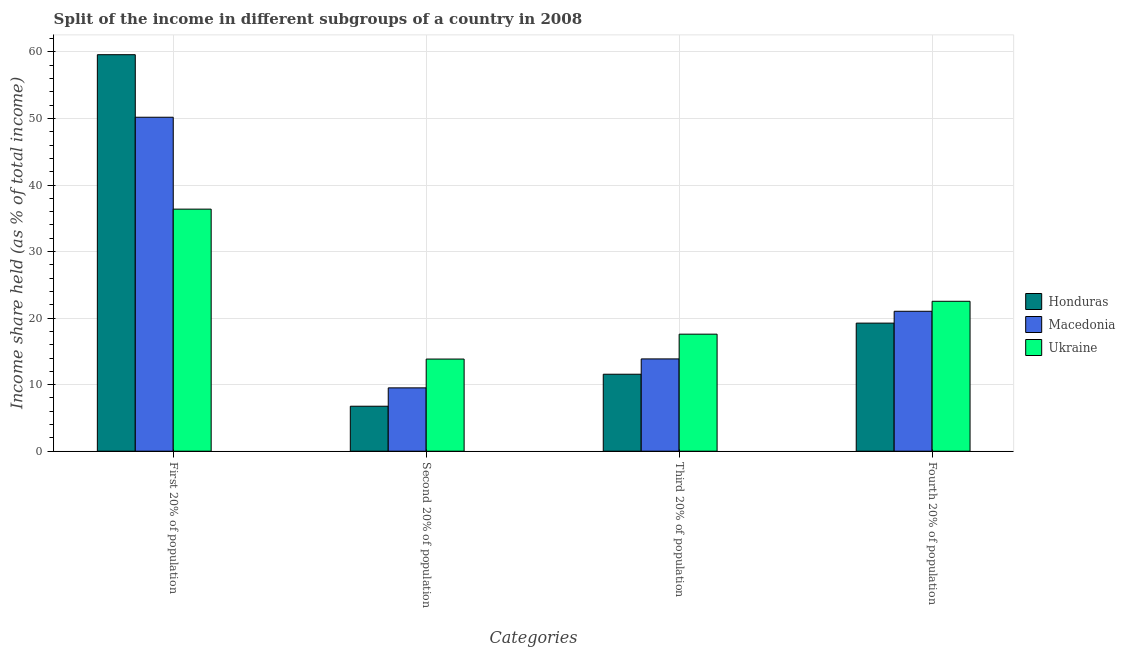How many groups of bars are there?
Your answer should be compact. 4. Are the number of bars per tick equal to the number of legend labels?
Your response must be concise. Yes. How many bars are there on the 2nd tick from the left?
Keep it short and to the point. 3. What is the label of the 4th group of bars from the left?
Offer a terse response. Fourth 20% of population. What is the share of the income held by fourth 20% of the population in Honduras?
Your answer should be very brief. 19.25. Across all countries, what is the maximum share of the income held by fourth 20% of the population?
Make the answer very short. 22.53. Across all countries, what is the minimum share of the income held by first 20% of the population?
Offer a very short reply. 36.38. In which country was the share of the income held by first 20% of the population maximum?
Your answer should be compact. Honduras. In which country was the share of the income held by third 20% of the population minimum?
Your response must be concise. Honduras. What is the total share of the income held by second 20% of the population in the graph?
Your answer should be very brief. 30.13. What is the difference between the share of the income held by third 20% of the population in Honduras and that in Ukraine?
Provide a succinct answer. -6.02. What is the difference between the share of the income held by third 20% of the population in Macedonia and the share of the income held by first 20% of the population in Honduras?
Your response must be concise. -45.72. What is the average share of the income held by fourth 20% of the population per country?
Keep it short and to the point. 20.94. What is the difference between the share of the income held by second 20% of the population and share of the income held by third 20% of the population in Ukraine?
Offer a very short reply. -3.74. In how many countries, is the share of the income held by first 20% of the population greater than 28 %?
Keep it short and to the point. 3. What is the ratio of the share of the income held by first 20% of the population in Honduras to that in Macedonia?
Offer a terse response. 1.19. What is the difference between the highest and the second highest share of the income held by first 20% of the population?
Give a very brief answer. 9.4. What is the difference between the highest and the lowest share of the income held by first 20% of the population?
Provide a succinct answer. 23.21. In how many countries, is the share of the income held by third 20% of the population greater than the average share of the income held by third 20% of the population taken over all countries?
Your response must be concise. 1. What does the 1st bar from the left in Second 20% of population represents?
Offer a terse response. Honduras. What does the 3rd bar from the right in Fourth 20% of population represents?
Your answer should be compact. Honduras. Is it the case that in every country, the sum of the share of the income held by first 20% of the population and share of the income held by second 20% of the population is greater than the share of the income held by third 20% of the population?
Keep it short and to the point. Yes. How many bars are there?
Offer a terse response. 12. How many countries are there in the graph?
Make the answer very short. 3. What is the difference between two consecutive major ticks on the Y-axis?
Ensure brevity in your answer.  10. Does the graph contain grids?
Give a very brief answer. Yes. Where does the legend appear in the graph?
Provide a succinct answer. Center right. How many legend labels are there?
Your answer should be very brief. 3. What is the title of the graph?
Offer a terse response. Split of the income in different subgroups of a country in 2008. What is the label or title of the X-axis?
Make the answer very short. Categories. What is the label or title of the Y-axis?
Give a very brief answer. Income share held (as % of total income). What is the Income share held (as % of total income) in Honduras in First 20% of population?
Provide a short and direct response. 59.59. What is the Income share held (as % of total income) in Macedonia in First 20% of population?
Offer a very short reply. 50.19. What is the Income share held (as % of total income) of Ukraine in First 20% of population?
Give a very brief answer. 36.38. What is the Income share held (as % of total income) of Honduras in Second 20% of population?
Provide a short and direct response. 6.76. What is the Income share held (as % of total income) of Macedonia in Second 20% of population?
Provide a short and direct response. 9.52. What is the Income share held (as % of total income) of Ukraine in Second 20% of population?
Make the answer very short. 13.85. What is the Income share held (as % of total income) of Honduras in Third 20% of population?
Provide a succinct answer. 11.57. What is the Income share held (as % of total income) of Macedonia in Third 20% of population?
Your response must be concise. 13.87. What is the Income share held (as % of total income) in Ukraine in Third 20% of population?
Keep it short and to the point. 17.59. What is the Income share held (as % of total income) in Honduras in Fourth 20% of population?
Keep it short and to the point. 19.25. What is the Income share held (as % of total income) in Macedonia in Fourth 20% of population?
Your answer should be very brief. 21.03. What is the Income share held (as % of total income) in Ukraine in Fourth 20% of population?
Ensure brevity in your answer.  22.53. Across all Categories, what is the maximum Income share held (as % of total income) of Honduras?
Keep it short and to the point. 59.59. Across all Categories, what is the maximum Income share held (as % of total income) of Macedonia?
Your response must be concise. 50.19. Across all Categories, what is the maximum Income share held (as % of total income) in Ukraine?
Make the answer very short. 36.38. Across all Categories, what is the minimum Income share held (as % of total income) in Honduras?
Ensure brevity in your answer.  6.76. Across all Categories, what is the minimum Income share held (as % of total income) of Macedonia?
Make the answer very short. 9.52. Across all Categories, what is the minimum Income share held (as % of total income) of Ukraine?
Provide a short and direct response. 13.85. What is the total Income share held (as % of total income) of Honduras in the graph?
Your answer should be very brief. 97.17. What is the total Income share held (as % of total income) in Macedonia in the graph?
Your answer should be very brief. 94.61. What is the total Income share held (as % of total income) in Ukraine in the graph?
Your response must be concise. 90.35. What is the difference between the Income share held (as % of total income) in Honduras in First 20% of population and that in Second 20% of population?
Offer a terse response. 52.83. What is the difference between the Income share held (as % of total income) of Macedonia in First 20% of population and that in Second 20% of population?
Give a very brief answer. 40.67. What is the difference between the Income share held (as % of total income) in Ukraine in First 20% of population and that in Second 20% of population?
Give a very brief answer. 22.53. What is the difference between the Income share held (as % of total income) in Honduras in First 20% of population and that in Third 20% of population?
Keep it short and to the point. 48.02. What is the difference between the Income share held (as % of total income) in Macedonia in First 20% of population and that in Third 20% of population?
Provide a short and direct response. 36.32. What is the difference between the Income share held (as % of total income) in Ukraine in First 20% of population and that in Third 20% of population?
Offer a terse response. 18.79. What is the difference between the Income share held (as % of total income) in Honduras in First 20% of population and that in Fourth 20% of population?
Your answer should be very brief. 40.34. What is the difference between the Income share held (as % of total income) in Macedonia in First 20% of population and that in Fourth 20% of population?
Offer a very short reply. 29.16. What is the difference between the Income share held (as % of total income) in Ukraine in First 20% of population and that in Fourth 20% of population?
Your response must be concise. 13.85. What is the difference between the Income share held (as % of total income) in Honduras in Second 20% of population and that in Third 20% of population?
Provide a succinct answer. -4.81. What is the difference between the Income share held (as % of total income) in Macedonia in Second 20% of population and that in Third 20% of population?
Make the answer very short. -4.35. What is the difference between the Income share held (as % of total income) in Ukraine in Second 20% of population and that in Third 20% of population?
Provide a succinct answer. -3.74. What is the difference between the Income share held (as % of total income) of Honduras in Second 20% of population and that in Fourth 20% of population?
Provide a short and direct response. -12.49. What is the difference between the Income share held (as % of total income) of Macedonia in Second 20% of population and that in Fourth 20% of population?
Provide a succinct answer. -11.51. What is the difference between the Income share held (as % of total income) in Ukraine in Second 20% of population and that in Fourth 20% of population?
Offer a terse response. -8.68. What is the difference between the Income share held (as % of total income) in Honduras in Third 20% of population and that in Fourth 20% of population?
Ensure brevity in your answer.  -7.68. What is the difference between the Income share held (as % of total income) in Macedonia in Third 20% of population and that in Fourth 20% of population?
Your answer should be compact. -7.16. What is the difference between the Income share held (as % of total income) in Ukraine in Third 20% of population and that in Fourth 20% of population?
Your answer should be compact. -4.94. What is the difference between the Income share held (as % of total income) in Honduras in First 20% of population and the Income share held (as % of total income) in Macedonia in Second 20% of population?
Ensure brevity in your answer.  50.07. What is the difference between the Income share held (as % of total income) in Honduras in First 20% of population and the Income share held (as % of total income) in Ukraine in Second 20% of population?
Offer a very short reply. 45.74. What is the difference between the Income share held (as % of total income) in Macedonia in First 20% of population and the Income share held (as % of total income) in Ukraine in Second 20% of population?
Your response must be concise. 36.34. What is the difference between the Income share held (as % of total income) of Honduras in First 20% of population and the Income share held (as % of total income) of Macedonia in Third 20% of population?
Ensure brevity in your answer.  45.72. What is the difference between the Income share held (as % of total income) in Honduras in First 20% of population and the Income share held (as % of total income) in Ukraine in Third 20% of population?
Your response must be concise. 42. What is the difference between the Income share held (as % of total income) of Macedonia in First 20% of population and the Income share held (as % of total income) of Ukraine in Third 20% of population?
Give a very brief answer. 32.6. What is the difference between the Income share held (as % of total income) of Honduras in First 20% of population and the Income share held (as % of total income) of Macedonia in Fourth 20% of population?
Provide a short and direct response. 38.56. What is the difference between the Income share held (as % of total income) of Honduras in First 20% of population and the Income share held (as % of total income) of Ukraine in Fourth 20% of population?
Provide a short and direct response. 37.06. What is the difference between the Income share held (as % of total income) of Macedonia in First 20% of population and the Income share held (as % of total income) of Ukraine in Fourth 20% of population?
Offer a very short reply. 27.66. What is the difference between the Income share held (as % of total income) of Honduras in Second 20% of population and the Income share held (as % of total income) of Macedonia in Third 20% of population?
Provide a succinct answer. -7.11. What is the difference between the Income share held (as % of total income) of Honduras in Second 20% of population and the Income share held (as % of total income) of Ukraine in Third 20% of population?
Offer a terse response. -10.83. What is the difference between the Income share held (as % of total income) of Macedonia in Second 20% of population and the Income share held (as % of total income) of Ukraine in Third 20% of population?
Provide a short and direct response. -8.07. What is the difference between the Income share held (as % of total income) in Honduras in Second 20% of population and the Income share held (as % of total income) in Macedonia in Fourth 20% of population?
Keep it short and to the point. -14.27. What is the difference between the Income share held (as % of total income) of Honduras in Second 20% of population and the Income share held (as % of total income) of Ukraine in Fourth 20% of population?
Ensure brevity in your answer.  -15.77. What is the difference between the Income share held (as % of total income) of Macedonia in Second 20% of population and the Income share held (as % of total income) of Ukraine in Fourth 20% of population?
Make the answer very short. -13.01. What is the difference between the Income share held (as % of total income) of Honduras in Third 20% of population and the Income share held (as % of total income) of Macedonia in Fourth 20% of population?
Offer a terse response. -9.46. What is the difference between the Income share held (as % of total income) of Honduras in Third 20% of population and the Income share held (as % of total income) of Ukraine in Fourth 20% of population?
Make the answer very short. -10.96. What is the difference between the Income share held (as % of total income) in Macedonia in Third 20% of population and the Income share held (as % of total income) in Ukraine in Fourth 20% of population?
Provide a short and direct response. -8.66. What is the average Income share held (as % of total income) in Honduras per Categories?
Offer a terse response. 24.29. What is the average Income share held (as % of total income) of Macedonia per Categories?
Your response must be concise. 23.65. What is the average Income share held (as % of total income) in Ukraine per Categories?
Your response must be concise. 22.59. What is the difference between the Income share held (as % of total income) of Honduras and Income share held (as % of total income) of Ukraine in First 20% of population?
Your response must be concise. 23.21. What is the difference between the Income share held (as % of total income) of Macedonia and Income share held (as % of total income) of Ukraine in First 20% of population?
Make the answer very short. 13.81. What is the difference between the Income share held (as % of total income) in Honduras and Income share held (as % of total income) in Macedonia in Second 20% of population?
Keep it short and to the point. -2.76. What is the difference between the Income share held (as % of total income) of Honduras and Income share held (as % of total income) of Ukraine in Second 20% of population?
Your answer should be very brief. -7.09. What is the difference between the Income share held (as % of total income) in Macedonia and Income share held (as % of total income) in Ukraine in Second 20% of population?
Provide a succinct answer. -4.33. What is the difference between the Income share held (as % of total income) in Honduras and Income share held (as % of total income) in Ukraine in Third 20% of population?
Provide a succinct answer. -6.02. What is the difference between the Income share held (as % of total income) in Macedonia and Income share held (as % of total income) in Ukraine in Third 20% of population?
Provide a short and direct response. -3.72. What is the difference between the Income share held (as % of total income) of Honduras and Income share held (as % of total income) of Macedonia in Fourth 20% of population?
Keep it short and to the point. -1.78. What is the difference between the Income share held (as % of total income) in Honduras and Income share held (as % of total income) in Ukraine in Fourth 20% of population?
Give a very brief answer. -3.28. What is the difference between the Income share held (as % of total income) in Macedonia and Income share held (as % of total income) in Ukraine in Fourth 20% of population?
Offer a very short reply. -1.5. What is the ratio of the Income share held (as % of total income) of Honduras in First 20% of population to that in Second 20% of population?
Provide a short and direct response. 8.82. What is the ratio of the Income share held (as % of total income) in Macedonia in First 20% of population to that in Second 20% of population?
Your answer should be compact. 5.27. What is the ratio of the Income share held (as % of total income) in Ukraine in First 20% of population to that in Second 20% of population?
Ensure brevity in your answer.  2.63. What is the ratio of the Income share held (as % of total income) of Honduras in First 20% of population to that in Third 20% of population?
Provide a short and direct response. 5.15. What is the ratio of the Income share held (as % of total income) of Macedonia in First 20% of population to that in Third 20% of population?
Give a very brief answer. 3.62. What is the ratio of the Income share held (as % of total income) of Ukraine in First 20% of population to that in Third 20% of population?
Ensure brevity in your answer.  2.07. What is the ratio of the Income share held (as % of total income) of Honduras in First 20% of population to that in Fourth 20% of population?
Provide a short and direct response. 3.1. What is the ratio of the Income share held (as % of total income) in Macedonia in First 20% of population to that in Fourth 20% of population?
Your answer should be very brief. 2.39. What is the ratio of the Income share held (as % of total income) of Ukraine in First 20% of population to that in Fourth 20% of population?
Provide a succinct answer. 1.61. What is the ratio of the Income share held (as % of total income) in Honduras in Second 20% of population to that in Third 20% of population?
Give a very brief answer. 0.58. What is the ratio of the Income share held (as % of total income) of Macedonia in Second 20% of population to that in Third 20% of population?
Give a very brief answer. 0.69. What is the ratio of the Income share held (as % of total income) in Ukraine in Second 20% of population to that in Third 20% of population?
Your answer should be very brief. 0.79. What is the ratio of the Income share held (as % of total income) in Honduras in Second 20% of population to that in Fourth 20% of population?
Offer a very short reply. 0.35. What is the ratio of the Income share held (as % of total income) of Macedonia in Second 20% of population to that in Fourth 20% of population?
Your response must be concise. 0.45. What is the ratio of the Income share held (as % of total income) of Ukraine in Second 20% of population to that in Fourth 20% of population?
Your answer should be compact. 0.61. What is the ratio of the Income share held (as % of total income) of Honduras in Third 20% of population to that in Fourth 20% of population?
Give a very brief answer. 0.6. What is the ratio of the Income share held (as % of total income) in Macedonia in Third 20% of population to that in Fourth 20% of population?
Provide a succinct answer. 0.66. What is the ratio of the Income share held (as % of total income) in Ukraine in Third 20% of population to that in Fourth 20% of population?
Ensure brevity in your answer.  0.78. What is the difference between the highest and the second highest Income share held (as % of total income) of Honduras?
Keep it short and to the point. 40.34. What is the difference between the highest and the second highest Income share held (as % of total income) in Macedonia?
Ensure brevity in your answer.  29.16. What is the difference between the highest and the second highest Income share held (as % of total income) in Ukraine?
Offer a terse response. 13.85. What is the difference between the highest and the lowest Income share held (as % of total income) of Honduras?
Give a very brief answer. 52.83. What is the difference between the highest and the lowest Income share held (as % of total income) in Macedonia?
Provide a succinct answer. 40.67. What is the difference between the highest and the lowest Income share held (as % of total income) of Ukraine?
Offer a very short reply. 22.53. 